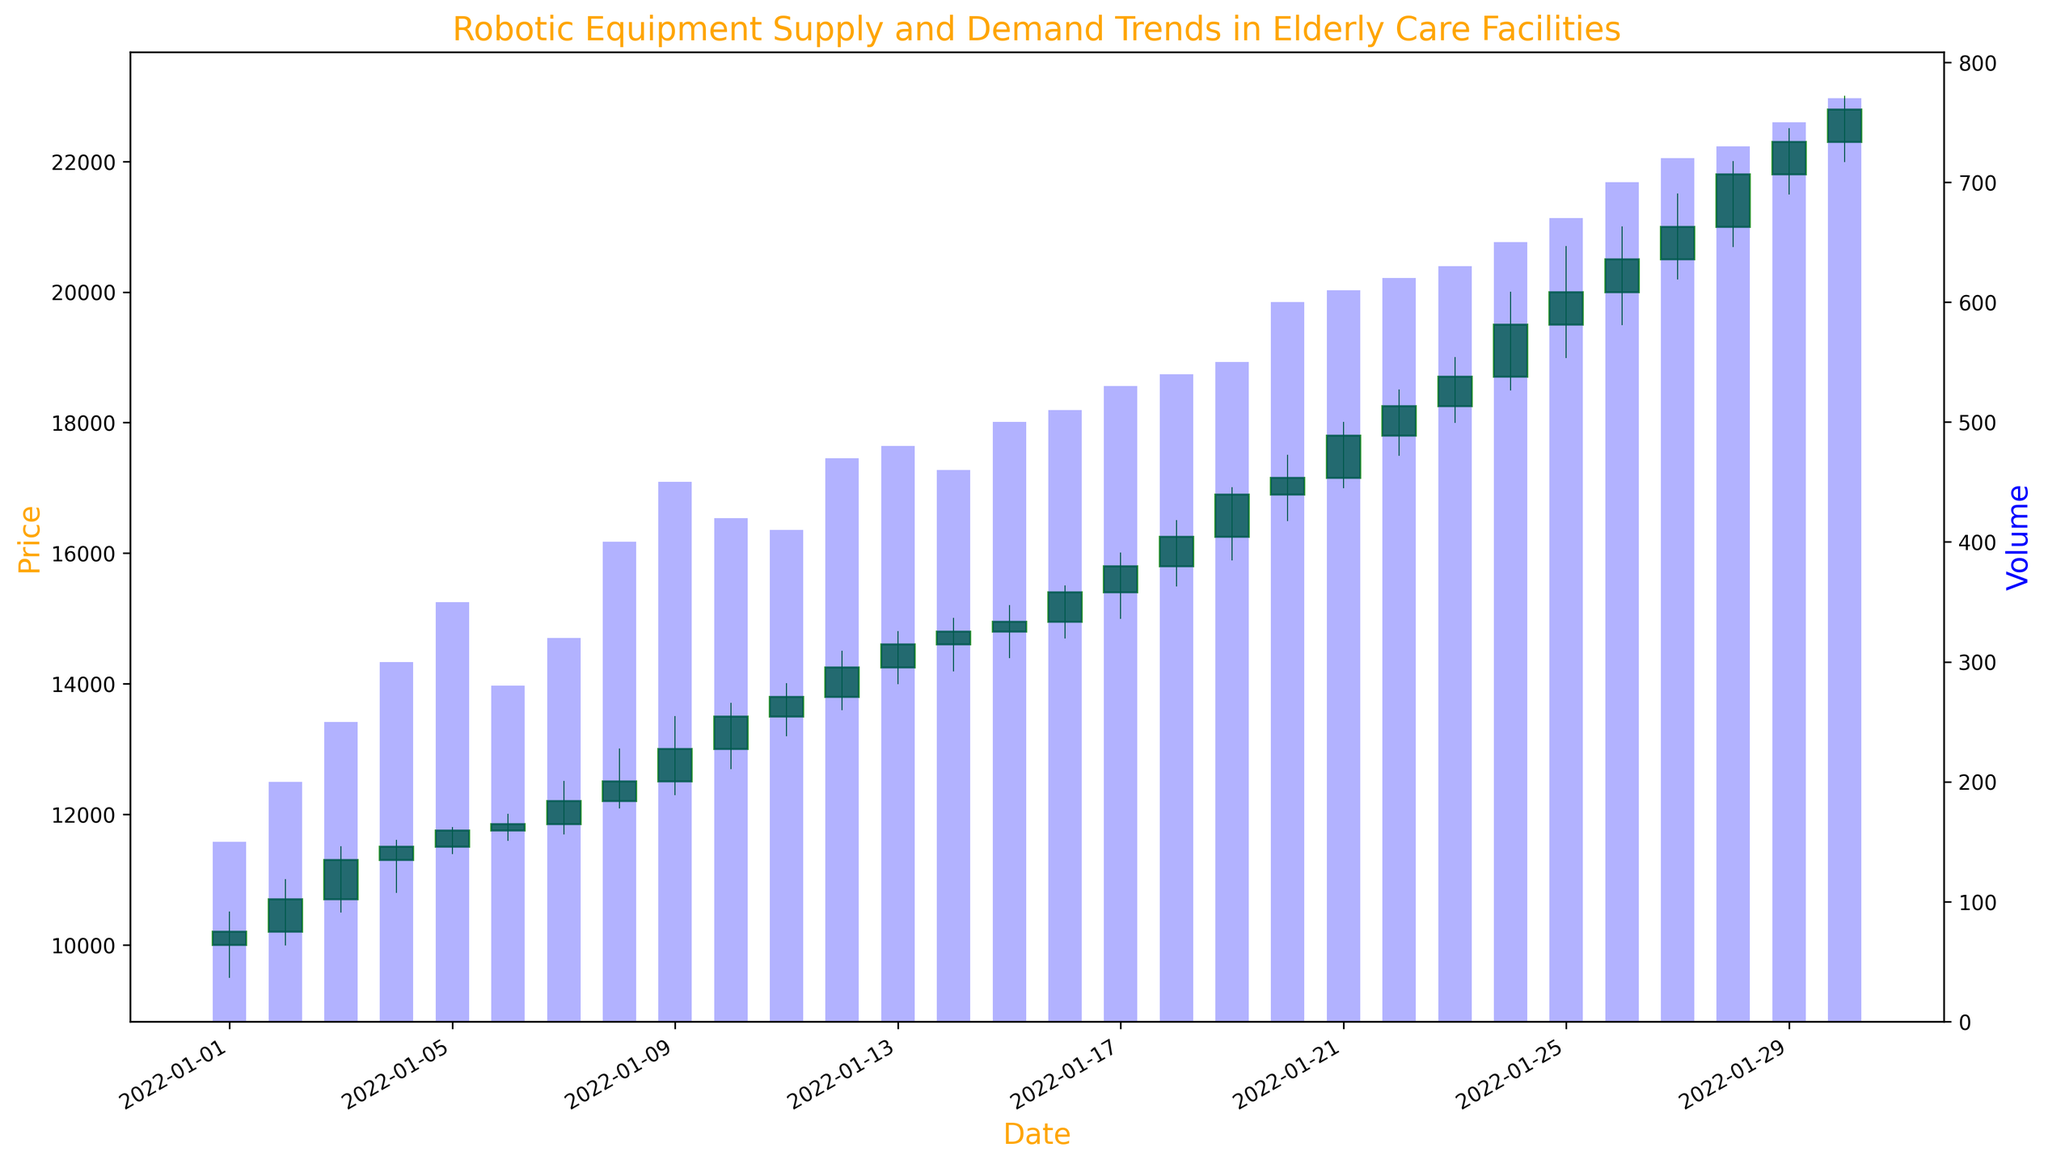What is the highest price reached in the month displayed on the chart? The highest price can be identified by looking at the top of the candlesticks' wicks. The highest point is on January 30th, where the high value reaches 23000.
Answer: 23000 Which date had the highest trading volume? The highest trading volume is shown by the tallest blue bar in the secondary axis. On January 30th, the volume reaches the highest at 770.
Answer: January 30 On which dates did the closing price increase consecutively for the longest period? To find this, we need to identify consecutive green candlesticks. From January 1st to January 12th, the closing price increased consecutively.
Answer: January 1 to January 12 What is the difference in closing price between January 1st and January 30th? The closing price on January 1st is 10200 and on January 30th is 22800. Subtracting these gives 22800 - 10200 = 12600.
Answer: 12600 How many days had a closing price higher than its opening price? By counting the number of green candlesticks, which indicate that the closing price is higher than the opening price, we find 24 such days.
Answer: 24 Compare the closing prices of January 10th and January 20th. Which is higher? The closing price on January 10th is 13500, and on January 20th is 17150. 17150 is higher than 13500.
Answer: January 20 Estimate the overall trend of the robotic equipment prices from January 1st to January 30th. Observing the overall pattern, the trend is upward as the prices generally increase from the starting value to the ending value.
Answer: Upward Which date had the smallest range between the high and low prices? To find this, look for the candlestick with the shortest wick. January 6th has the smallest range with a high of 12000 and a low of 11600, giving a range of 400.
Answer: January 6 On which date did the volume reach 600? Looking at the blue bars that represent volume, the volume on January 20th is 600.
Answer: January 20 Compare the volumes on January 15th and January 25th. Which had a higher volume? The volume on January 15th is 500, and on January 25th is 670. 670 is higher than 500.
Answer: January 25 